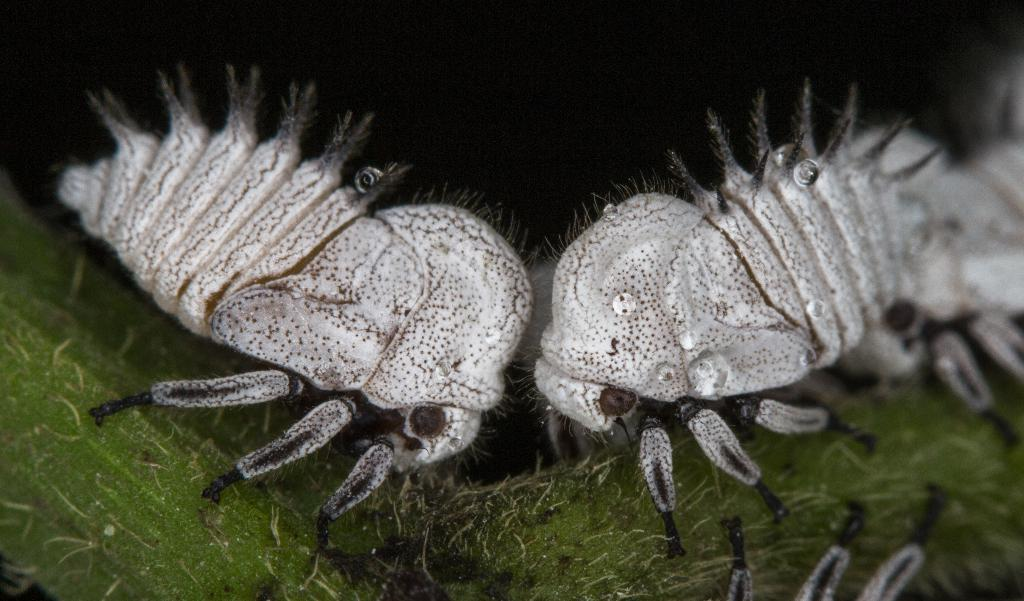What type of creatures are present in the image? There are insects in the image. What surface are the insects located on? The insects are on a green colored object. What can be observed about the background of the image? The background of the image is dark. Where is the shop located in the image? There is no shop present in the image. What type of cup is being used by the insects in the image? There are no cups present in the image; the insects are on a green colored object. 